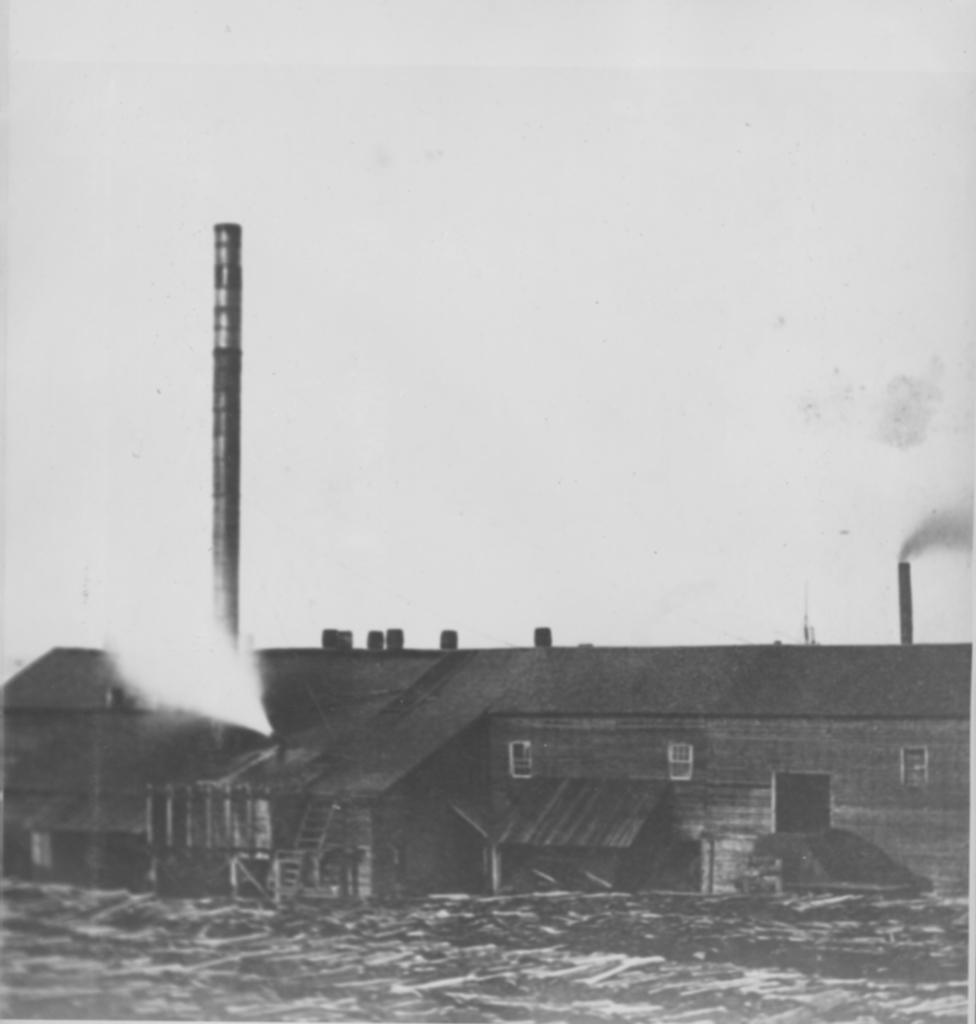What type of structure is present in the image? There is a building in the image. Can you describe the smoke in the image? Smoke is visible on both sides of the image. What is the color scheme of the image? The image is black and white in color. What type of straw is being used to mark the territory in the image? There is no straw or territory present in the image; it features a building and smoke. What type of industry is depicted in the image? The image does not depict any specific industry; it only shows a building and smoke. 